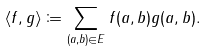Convert formula to latex. <formula><loc_0><loc_0><loc_500><loc_500>\langle f , g \rangle \coloneqq \sum _ { ( a , b ) \in E } f ( a , b ) g ( a , b ) .</formula> 